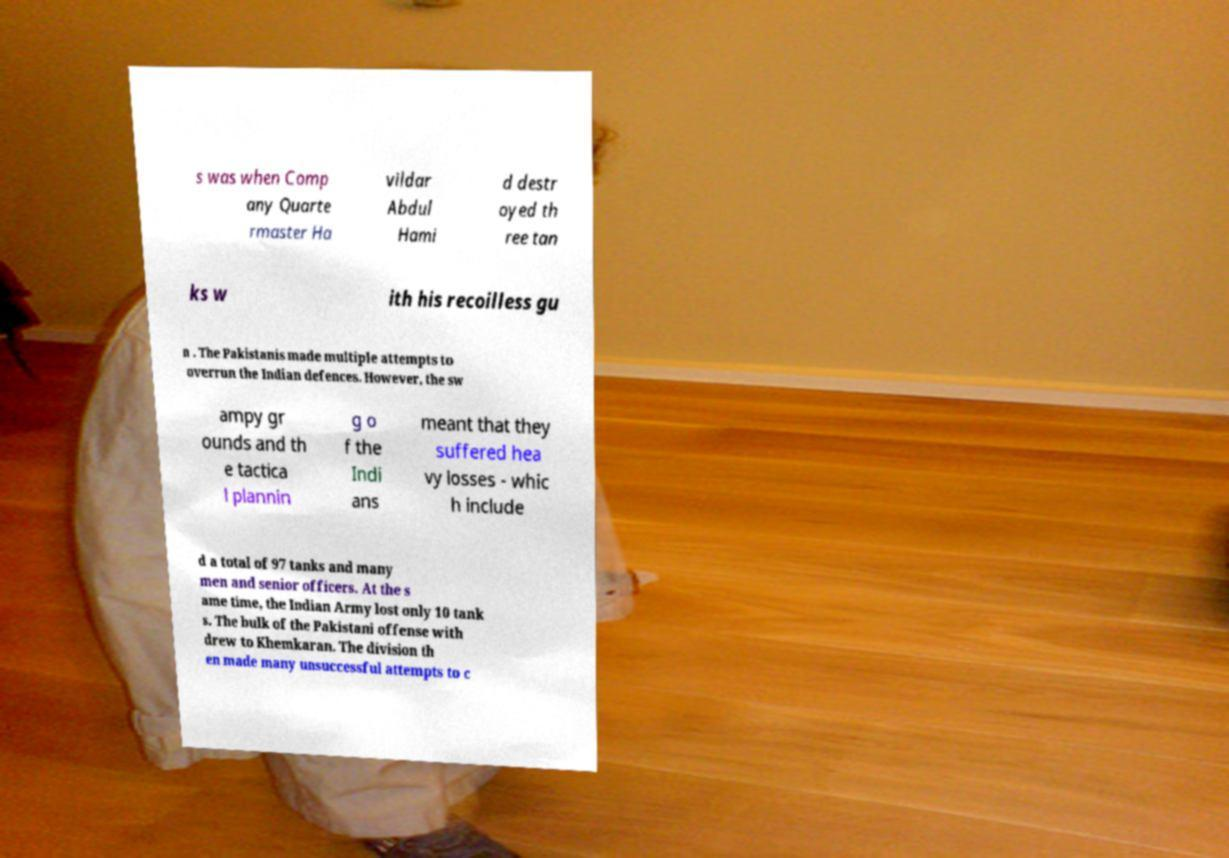Can you read and provide the text displayed in the image?This photo seems to have some interesting text. Can you extract and type it out for me? s was when Comp any Quarte rmaster Ha vildar Abdul Hami d destr oyed th ree tan ks w ith his recoilless gu n . The Pakistanis made multiple attempts to overrun the Indian defences. However, the sw ampy gr ounds and th e tactica l plannin g o f the Indi ans meant that they suffered hea vy losses - whic h include d a total of 97 tanks and many men and senior officers. At the s ame time, the Indian Army lost only 10 tank s. The bulk of the Pakistani offense with drew to Khemkaran. The division th en made many unsuccessful attempts to c 